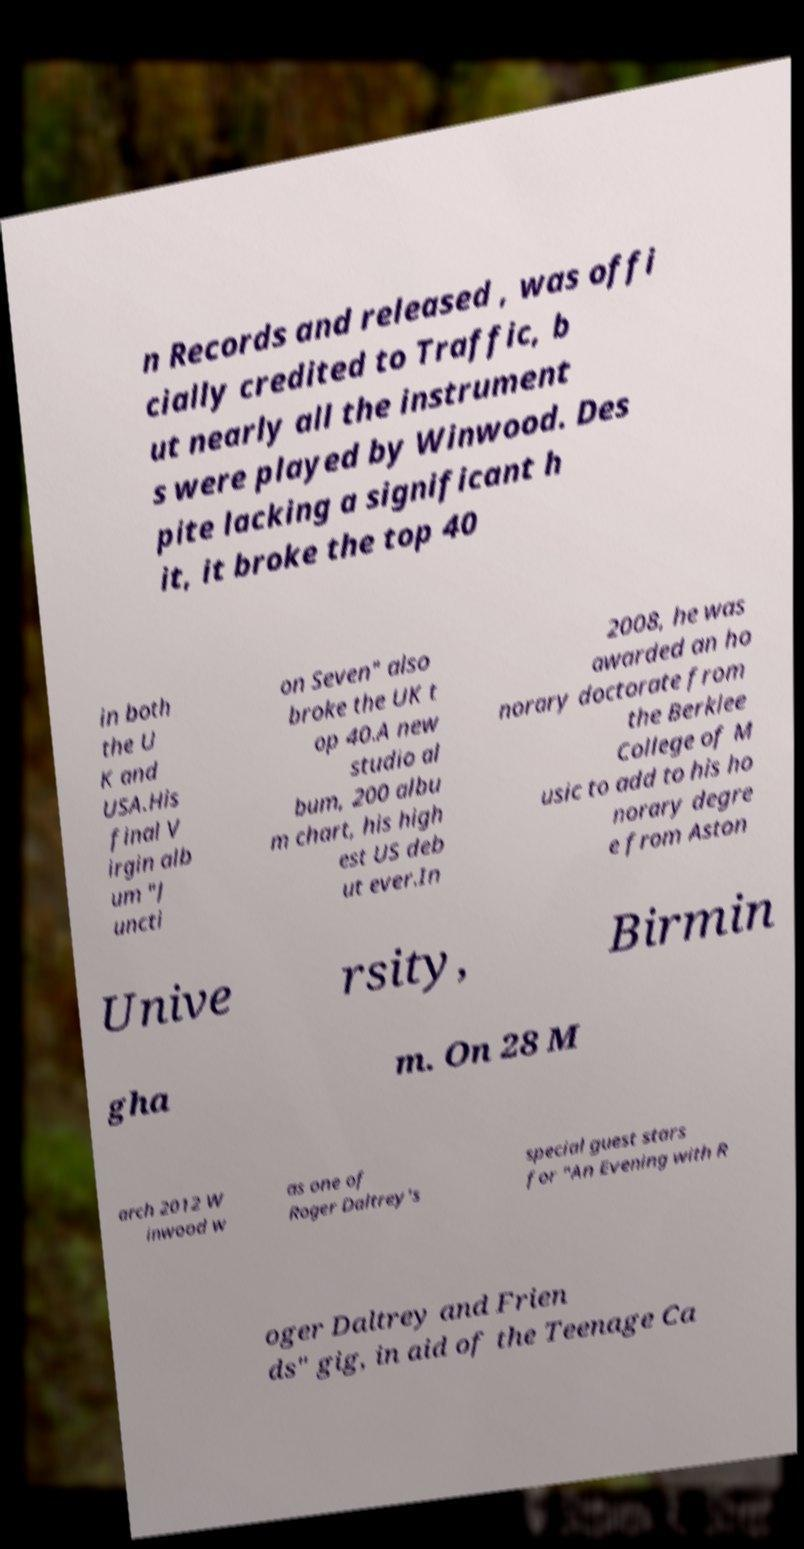There's text embedded in this image that I need extracted. Can you transcribe it verbatim? n Records and released , was offi cially credited to Traffic, b ut nearly all the instrument s were played by Winwood. Des pite lacking a significant h it, it broke the top 40 in both the U K and USA.His final V irgin alb um "J uncti on Seven" also broke the UK t op 40.A new studio al bum, 200 albu m chart, his high est US deb ut ever.In 2008, he was awarded an ho norary doctorate from the Berklee College of M usic to add to his ho norary degre e from Aston Unive rsity, Birmin gha m. On 28 M arch 2012 W inwood w as one of Roger Daltrey's special guest stars for "An Evening with R oger Daltrey and Frien ds" gig, in aid of the Teenage Ca 